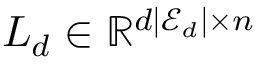<formula> <loc_0><loc_0><loc_500><loc_500>L _ { d } \in \mathbb { R } ^ { d | \mathcal { E } _ { d } | \times n }</formula> 